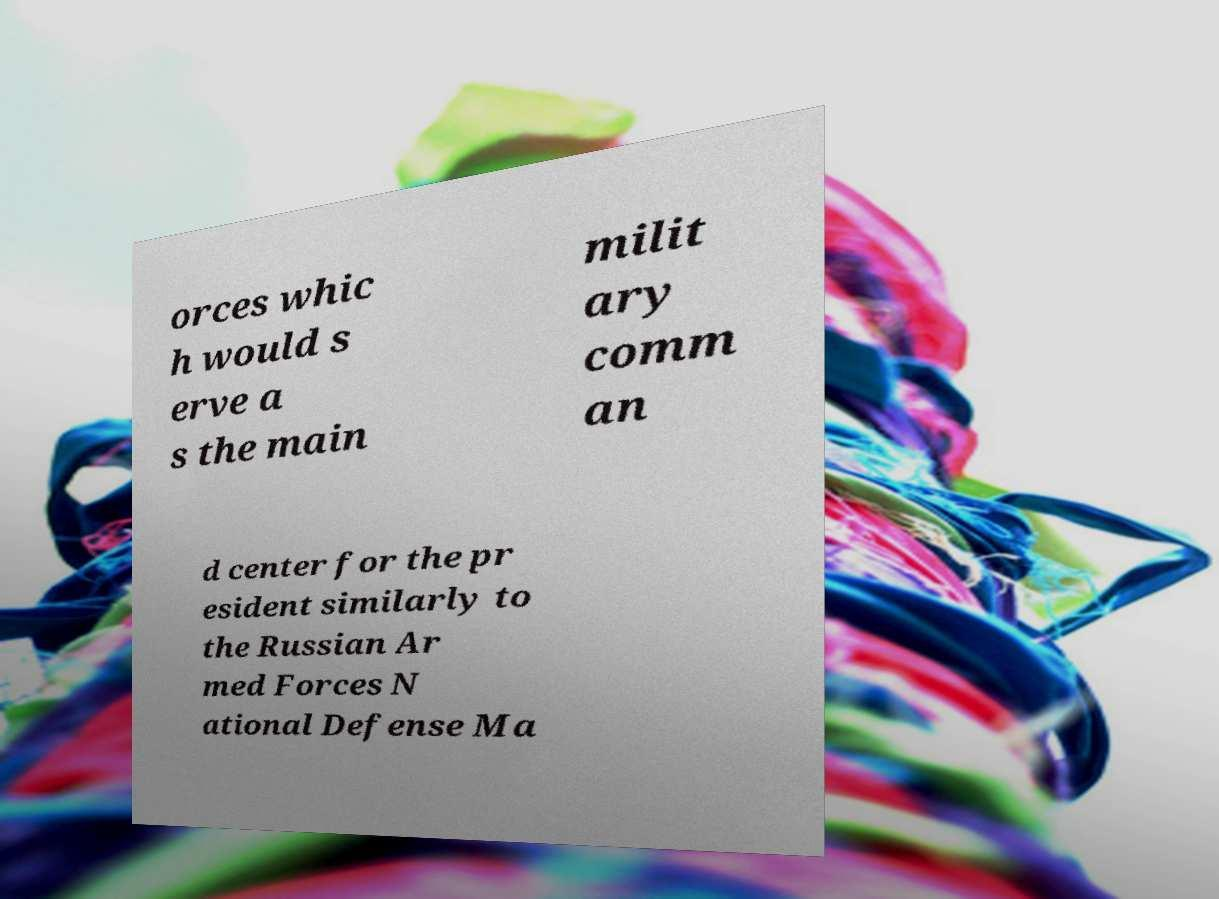Can you read and provide the text displayed in the image?This photo seems to have some interesting text. Can you extract and type it out for me? orces whic h would s erve a s the main milit ary comm an d center for the pr esident similarly to the Russian Ar med Forces N ational Defense Ma 